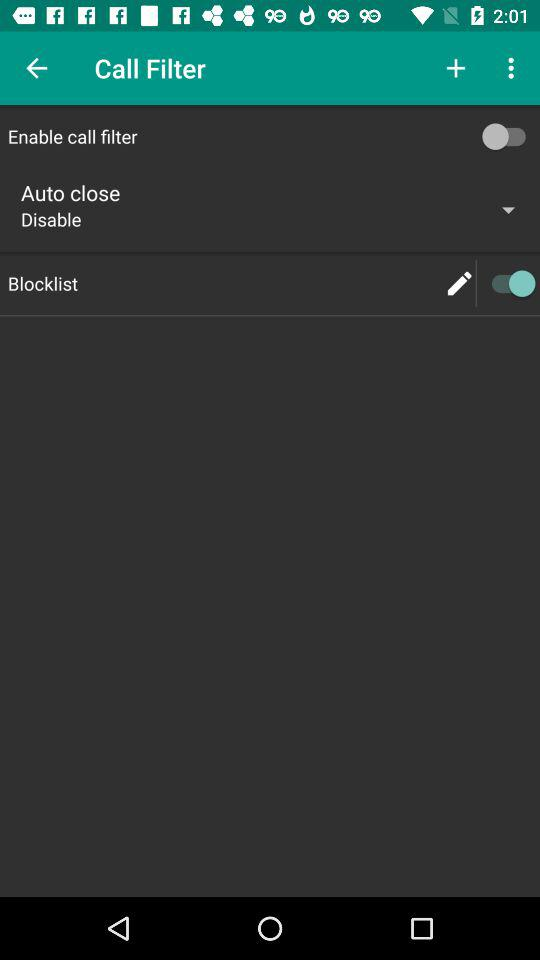What is the status of "Enable call filter"? The status of "Enable call filter" is "off". 